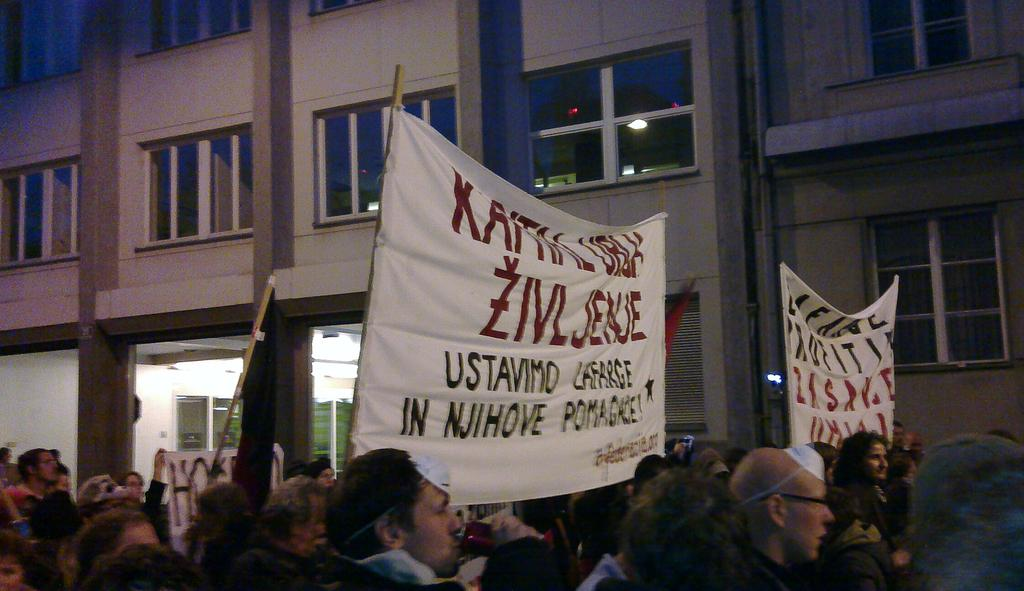What are the people at the bottom of the image doing? The people at the bottom of the image are holding placards and sticks. What might the placards and sticks be used for? The placards and sticks might be used for a protest or demonstration. What can be seen in the background of the image? There are buildings and glass windows in the background of the image. What type of butter is being spread on the glass windows in the image? There is no butter present in the image, and the glass windows are not being used for spreading butter. 